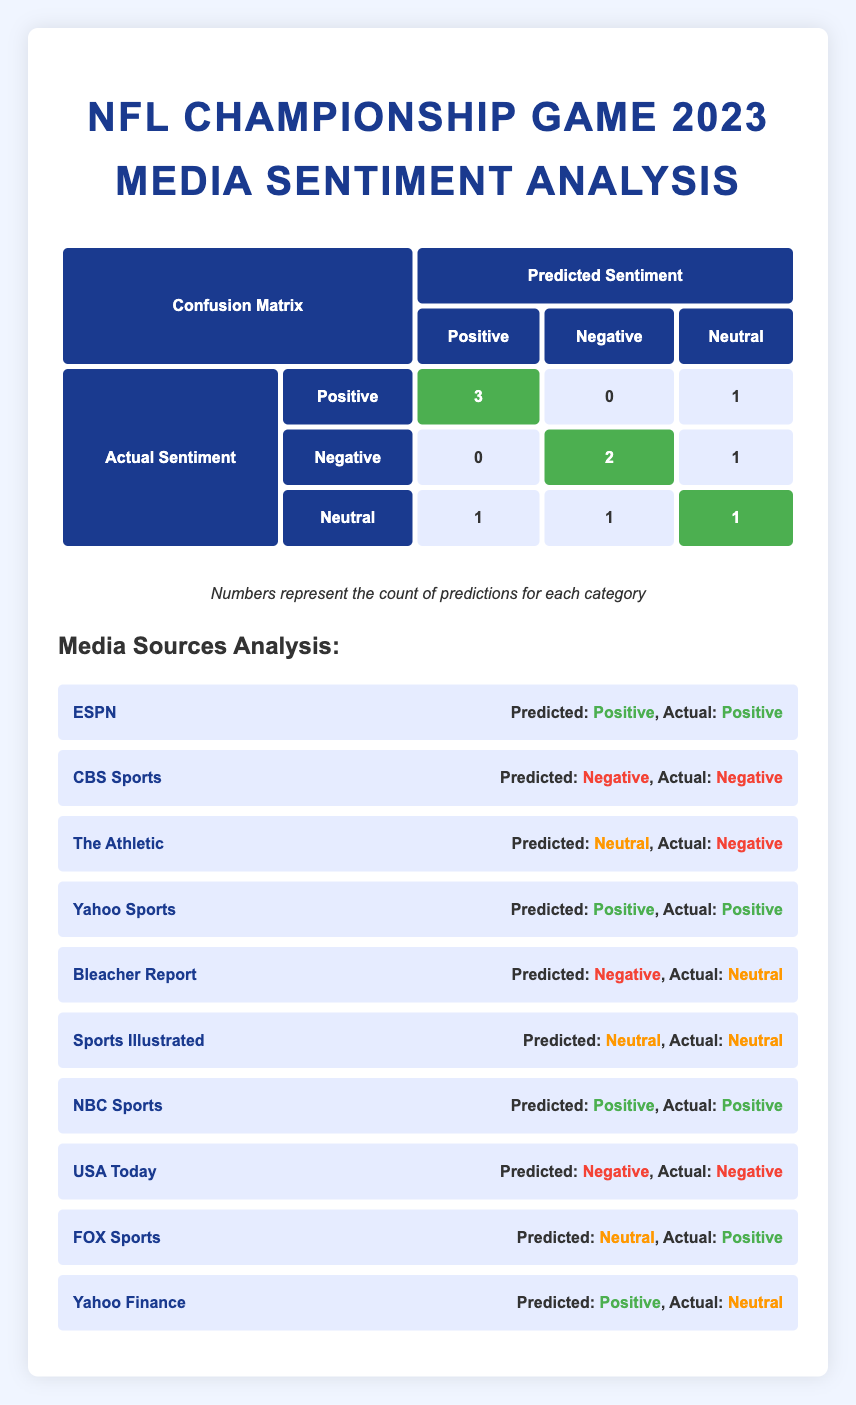How many media sources predicted the actual sentiment as Positive? By examining the table, we can see that there are four media sources that predicted the sentiment as Positive: ESPN, Yahoo Sports, NBC Sports, and Yahoo Finance. Hence, we count these instances in the table.
Answer: 4 What is the total number of Neutral sentiments predicted? Looking at the predicted sentiment counts from the confusion matrix, we find that Neutral was predicted 3 times (counting the columns under "Neutral").
Answer: 3 Did any media source predict a Positive sentiment when the actual sentiment was Negative? From the table, we can see that The Athletic predicted Neutral when the actual was Negative but never predicted Positive for Negative. Therefore, there are no instances where this occurs.
Answer: No What is the sum of the True Positives and True Negatives? True Positives (TP) are represented by the count of correctly predicted Positive sentiments (3 from the first row) and True Negatives (TN) by the count of correctly predicted Negative sentiments (2 from the second row). Thus the sum is 3 (TP) + 2 (TN) = 5.
Answer: 5 What percentage of predictions were Neutral? There are 3 Neutral predictions out of a total of 10 predictions. To find the percentage, we use the formula (number of Neutral predictions / total predictions) * 100. Therefore, this would be (3 / 10) * 100 = 30%.
Answer: 30% Which media source predicted the most incorrect sentiment and what was that sentiment? Analyzing the sources, Bleacher Report predicted Negative while the actual sentiment was Neutral, and FOX Sports predicted Neutral when the actual sentiment was Positive. Both cases represent incorrect predictions, but since Bleacher Report only has one incorrect prediction, the maximum would refer to maximum incorrect unique prediction instances.
Answer: Bleacher Report, Negative How many media sources predicted the same sentiment as the actual that was also Neutral? By referencing the sources listed, only Sports Illustrated predicted Neutral and was correct when the actual sentiment was also Neutral (from the table). Thus, there is only one source fulfilling this condition.
Answer: 1 What is the count of predictions that were incorrectly identified as Positive when the actual was Neutral? According to the confusion matrix, the only instance is Yahoo Finance that predicted Positive for an actual Neutral sentiment, giving us one incorrect prediction here. Therefore, we count that instance: 1.
Answer: 1 